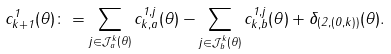<formula> <loc_0><loc_0><loc_500><loc_500>c ^ { 1 } _ { k + 1 } ( \theta ) \colon = \sum _ { j \in { \mathcal { J } } ^ { k } _ { a } ( \theta ) } c ^ { 1 , j } _ { k , a } ( \theta ) - \sum _ { j \in { \mathcal { J } } ^ { k } _ { b } ( \theta ) } c ^ { 1 , j } _ { k , b } ( \theta ) + \delta _ { ( 2 , ( 0 , k ) ) } ( \theta ) .</formula> 